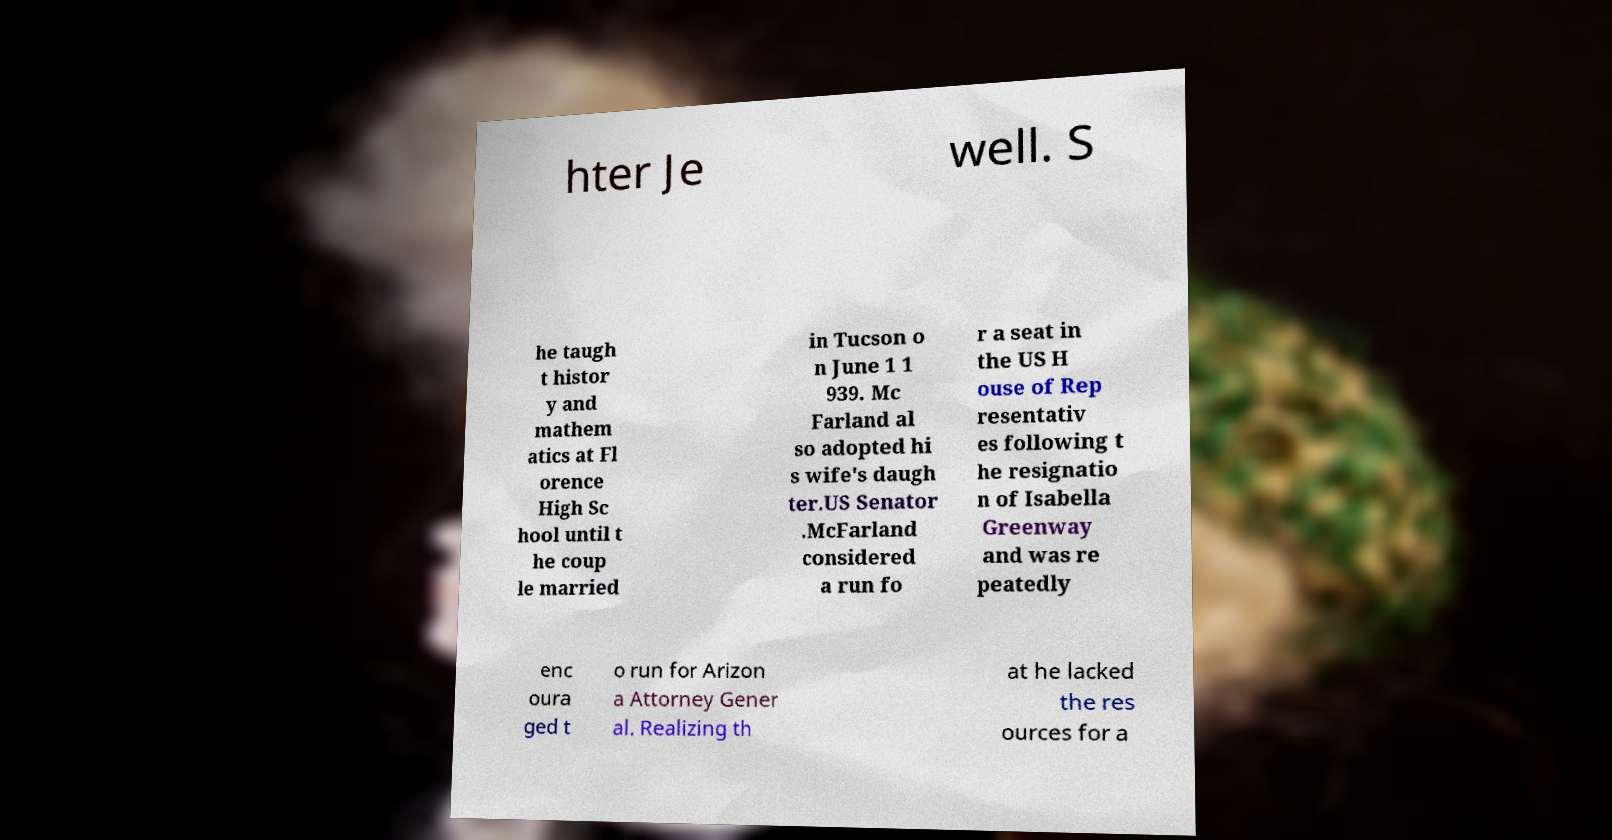For documentation purposes, I need the text within this image transcribed. Could you provide that? hter Je well. S he taugh t histor y and mathem atics at Fl orence High Sc hool until t he coup le married in Tucson o n June 1 1 939. Mc Farland al so adopted hi s wife's daugh ter.US Senator .McFarland considered a run fo r a seat in the US H ouse of Rep resentativ es following t he resignatio n of Isabella Greenway and was re peatedly enc oura ged t o run for Arizon a Attorney Gener al. Realizing th at he lacked the res ources for a 